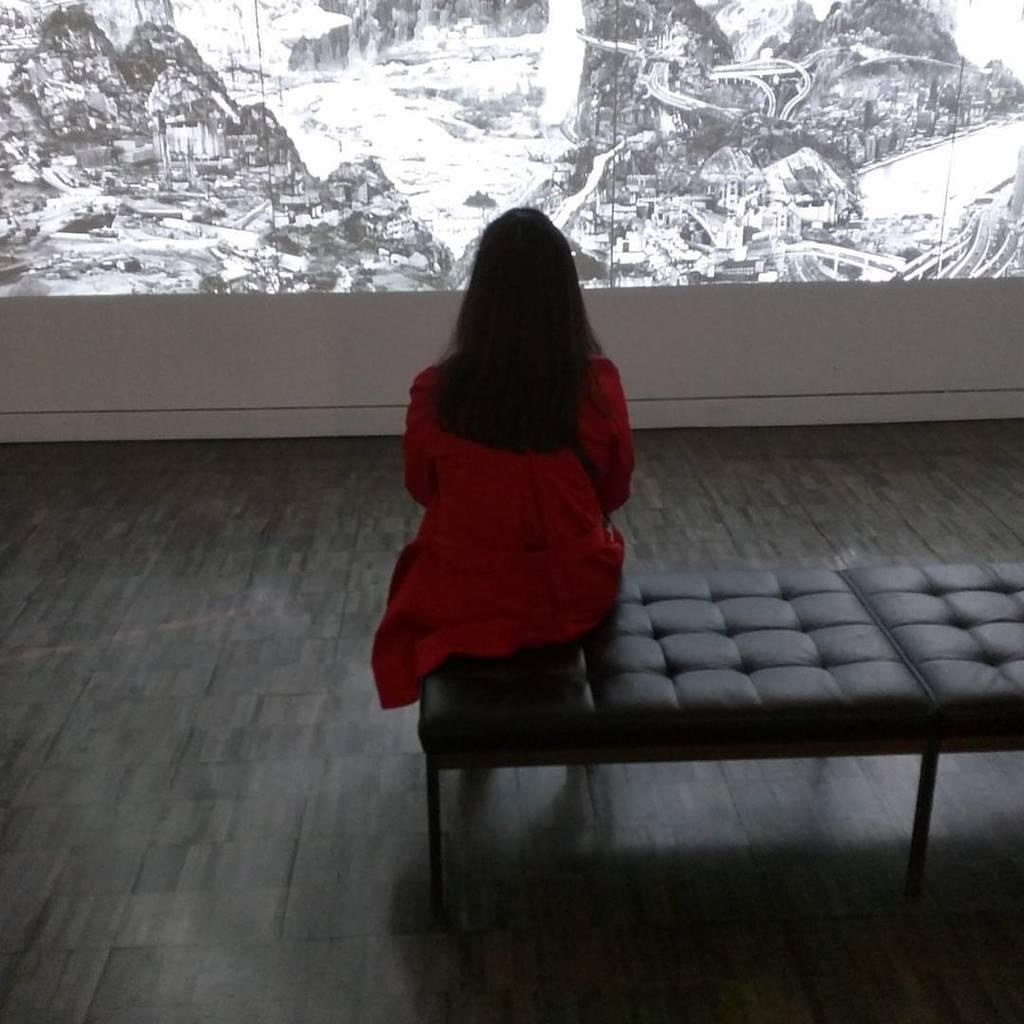Who is present in the image? There is a woman in the image. What is the woman doing in the image? The woman is sitting on a sofa bed and looking at a picture. What type of hospital is visible in the image? There is no hospital present in the image; it features a woman sitting on a sofa bed and looking at a picture. How long does the kiss between the woman and the man last in the image? There is no man or kiss present in the image. 